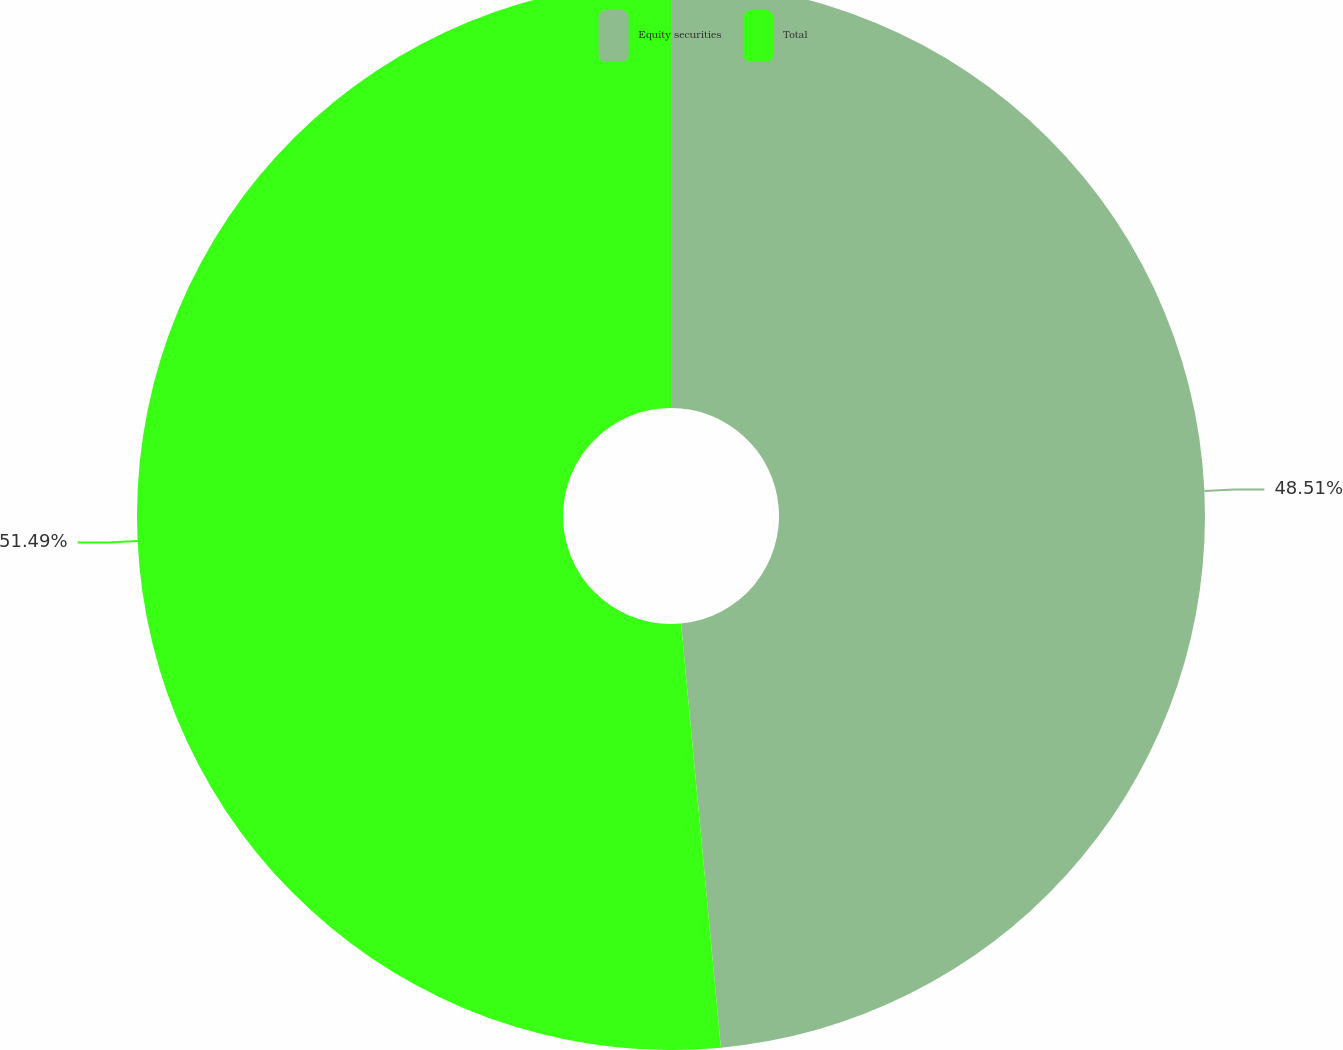<chart> <loc_0><loc_0><loc_500><loc_500><pie_chart><fcel>Equity securities<fcel>Total<nl><fcel>48.51%<fcel>51.49%<nl></chart> 